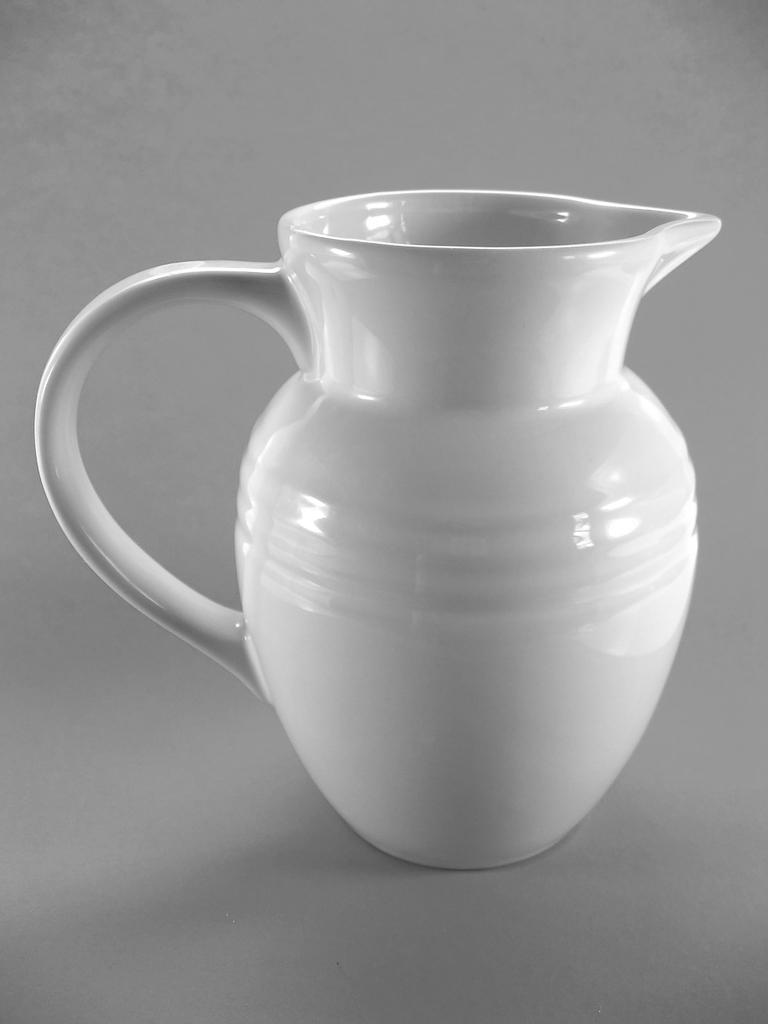What object is the main focus of the image? There is a white jar in the image. What color is the background of the image? The background of the image has a grey color. What type of learning material can be seen in the image? There is no learning material present in the image; it only features a white jar and a grey background. 